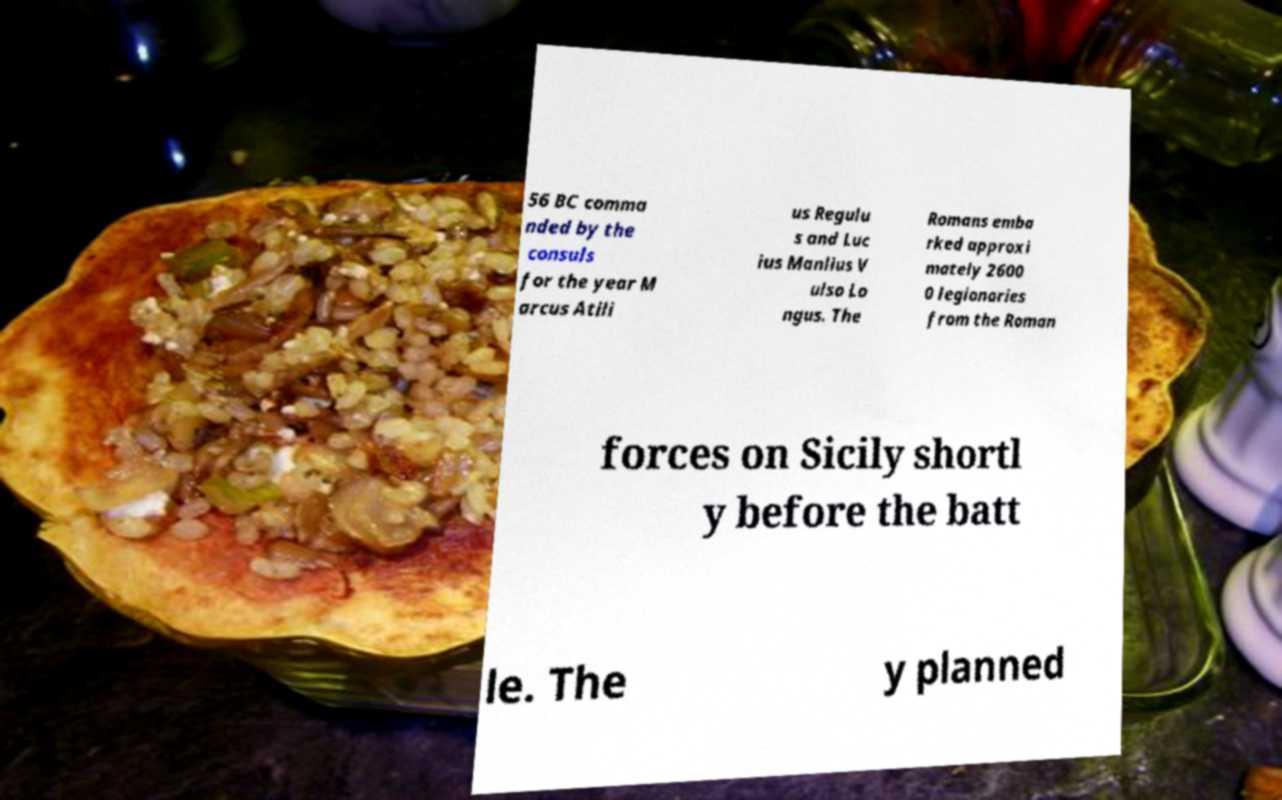Could you extract and type out the text from this image? 56 BC comma nded by the consuls for the year M arcus Atili us Regulu s and Luc ius Manlius V ulso Lo ngus. The Romans emba rked approxi mately 2600 0 legionaries from the Roman forces on Sicily shortl y before the batt le. The y planned 